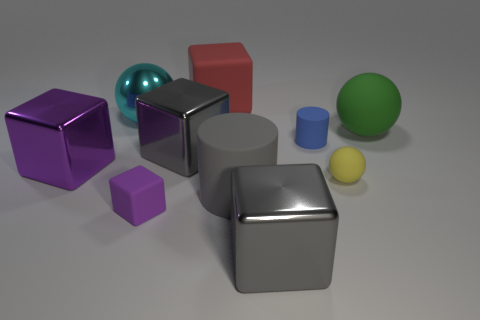Subtract all matte spheres. How many spheres are left? 1 Subtract 2 cylinders. How many cylinders are left? 0 Subtract all blue cylinders. How many cylinders are left? 1 Subtract all cylinders. How many objects are left? 8 Subtract all purple blocks. How many gray cylinders are left? 1 Subtract all big purple spheres. Subtract all cyan metal spheres. How many objects are left? 9 Add 8 gray metallic objects. How many gray metallic objects are left? 10 Add 7 brown metal spheres. How many brown metal spheres exist? 7 Subtract 2 purple cubes. How many objects are left? 8 Subtract all blue balls. Subtract all green cylinders. How many balls are left? 3 